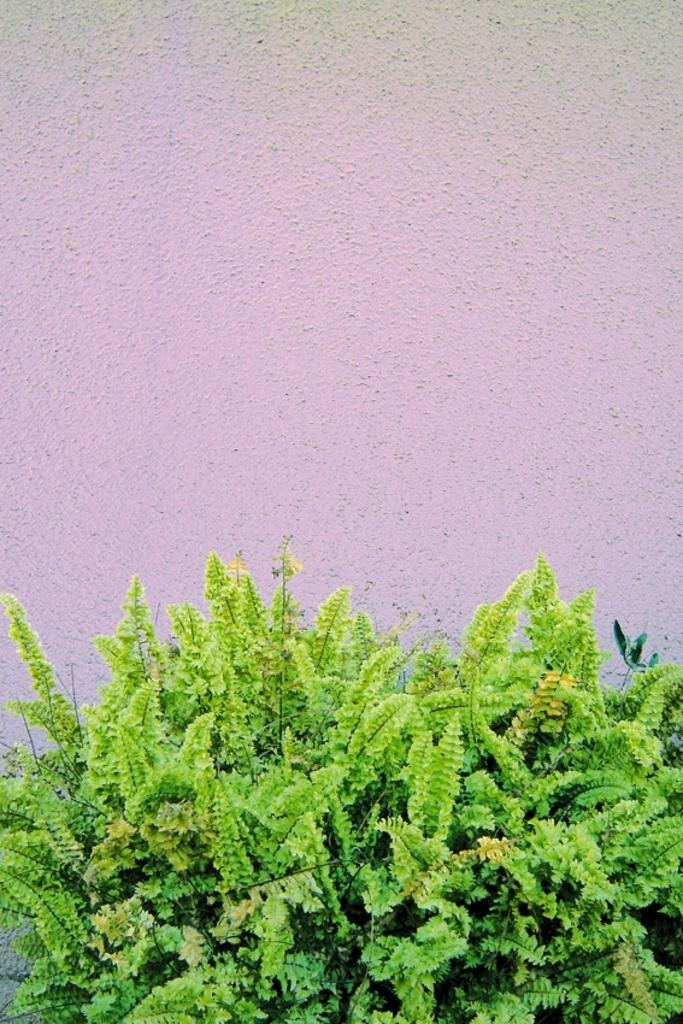What type of plants can be seen in the image? There are green plants in the image. What is visible in the background of the image? There is a wall in the background of the image. What type of quartz can be seen in the image? There is no quartz present in the image; it features green plants and a wall in the background. What achievements has the goose accomplished in the image? There is no goose present in the image, so there are no achievements to discuss. 